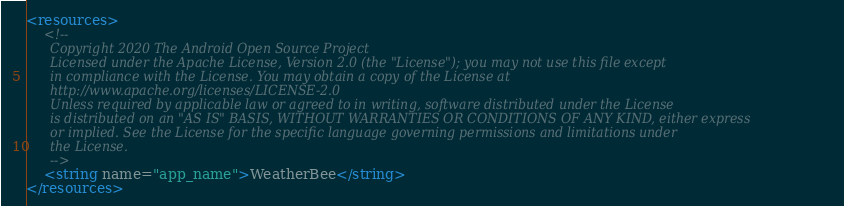<code> <loc_0><loc_0><loc_500><loc_500><_XML_><resources>
    <!--
      Copyright 2020 The Android Open Source Project
      Licensed under the Apache License, Version 2.0 (the "License"); you may not use this file except
      in compliance with the License. You may obtain a copy of the License at
      http://www.apache.org/licenses/LICENSE-2.0
      Unless required by applicable law or agreed to in writing, software distributed under the License
      is distributed on an "AS IS" BASIS, WITHOUT WARRANTIES OR CONDITIONS OF ANY KIND, either express
      or implied. See the License for the specific language governing permissions and limitations under
      the License.
      -->
    <string name="app_name">WeatherBee</string>
</resources></code> 